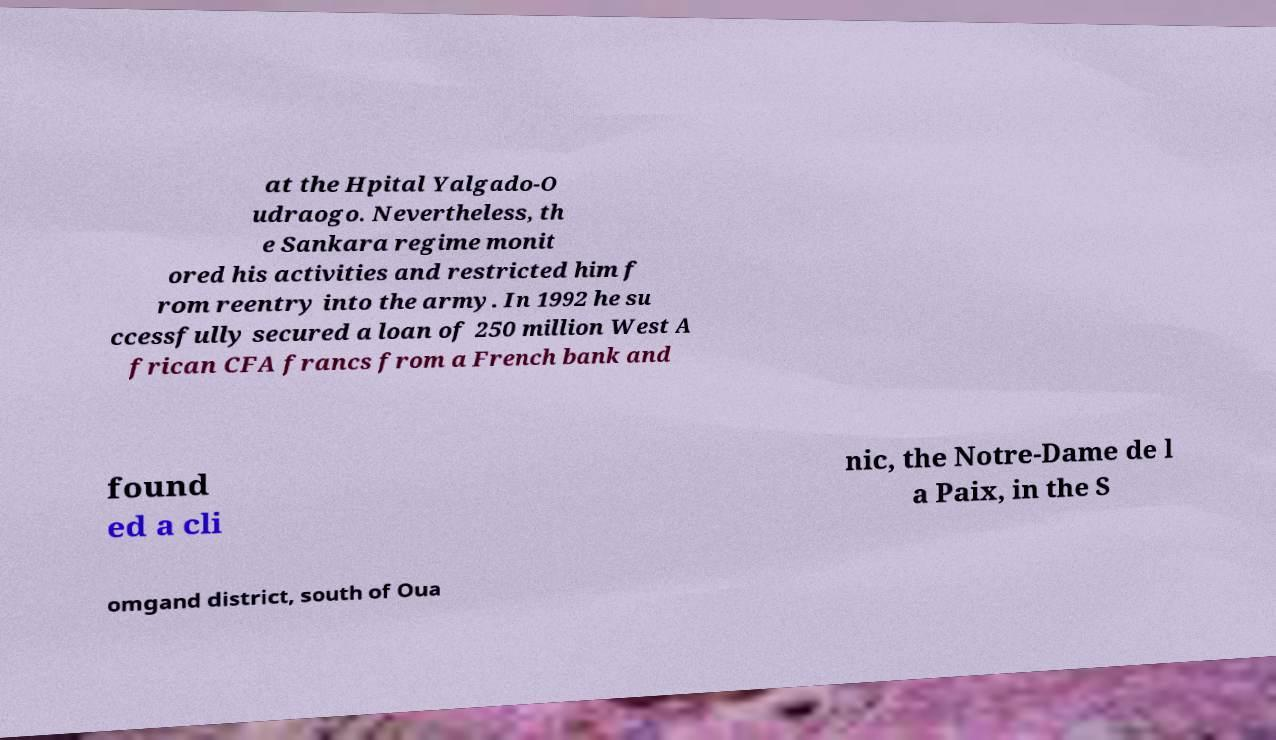There's text embedded in this image that I need extracted. Can you transcribe it verbatim? at the Hpital Yalgado-O udraogo. Nevertheless, th e Sankara regime monit ored his activities and restricted him f rom reentry into the army. In 1992 he su ccessfully secured a loan of 250 million West A frican CFA francs from a French bank and found ed a cli nic, the Notre-Dame de l a Paix, in the S omgand district, south of Oua 